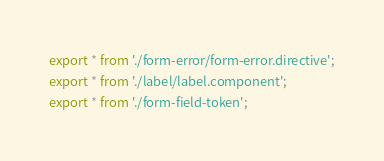<code> <loc_0><loc_0><loc_500><loc_500><_TypeScript_>export * from './form-error/form-error.directive';
export * from './label/label.component';
export * from './form-field-token';
</code> 